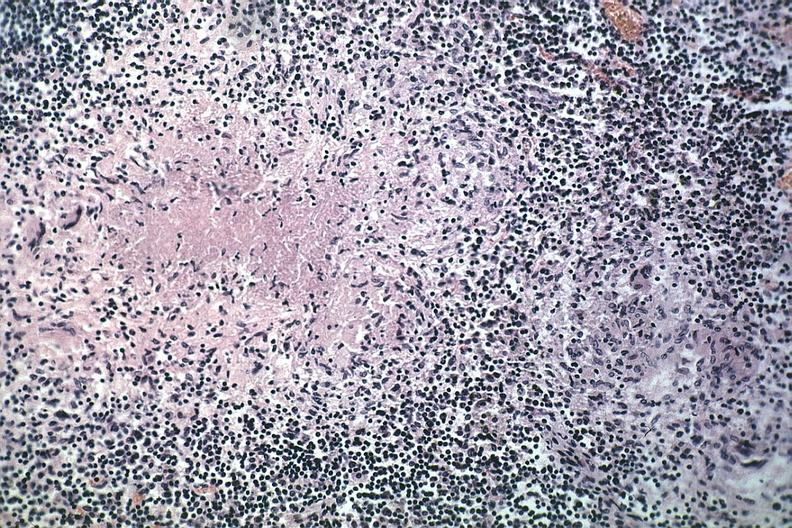s tuberculosis present?
Answer the question using a single word or phrase. Yes 